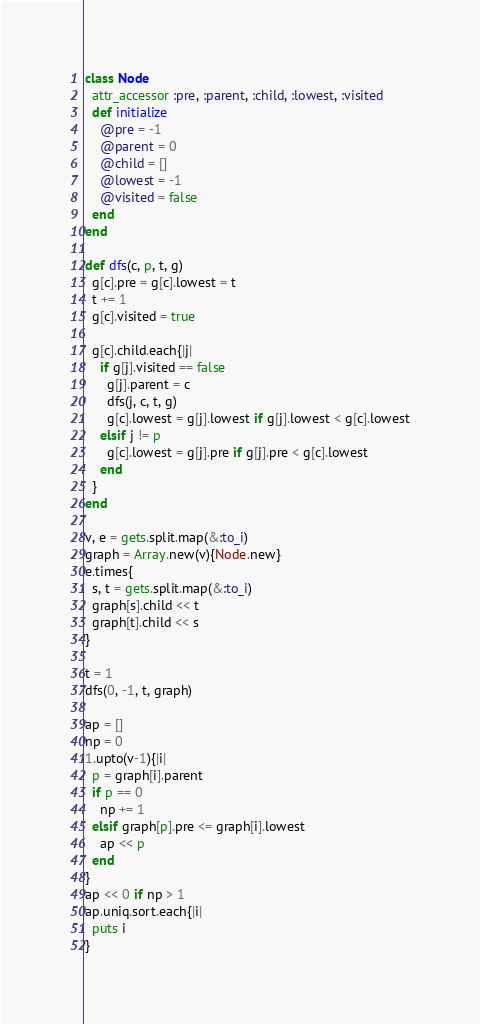<code> <loc_0><loc_0><loc_500><loc_500><_Ruby_>class Node
  attr_accessor :pre, :parent, :child, :lowest, :visited
  def initialize
    @pre = -1
    @parent = 0
    @child = []
    @lowest = -1
    @visited = false
  end
end

def dfs(c, p, t, g)
  g[c].pre = g[c].lowest = t
  t += 1
  g[c].visited = true

  g[c].child.each{|j|
    if g[j].visited == false
      g[j].parent = c
      dfs(j, c, t, g)
      g[c].lowest = g[j].lowest if g[j].lowest < g[c].lowest
    elsif j != p
      g[c].lowest = g[j].pre if g[j].pre < g[c].lowest
    end
  }
end

v, e = gets.split.map(&:to_i)
graph = Array.new(v){Node.new}
e.times{
  s, t = gets.split.map(&:to_i)
  graph[s].child << t
  graph[t].child << s
}

t = 1
dfs(0, -1, t, graph)

ap = []
np = 0
1.upto(v-1){|i|
  p = graph[i].parent
  if p == 0
    np += 1
  elsif graph[p].pre <= graph[i].lowest
    ap << p
  end
}
ap << 0 if np > 1
ap.uniq.sort.each{|i|
  puts i
}</code> 